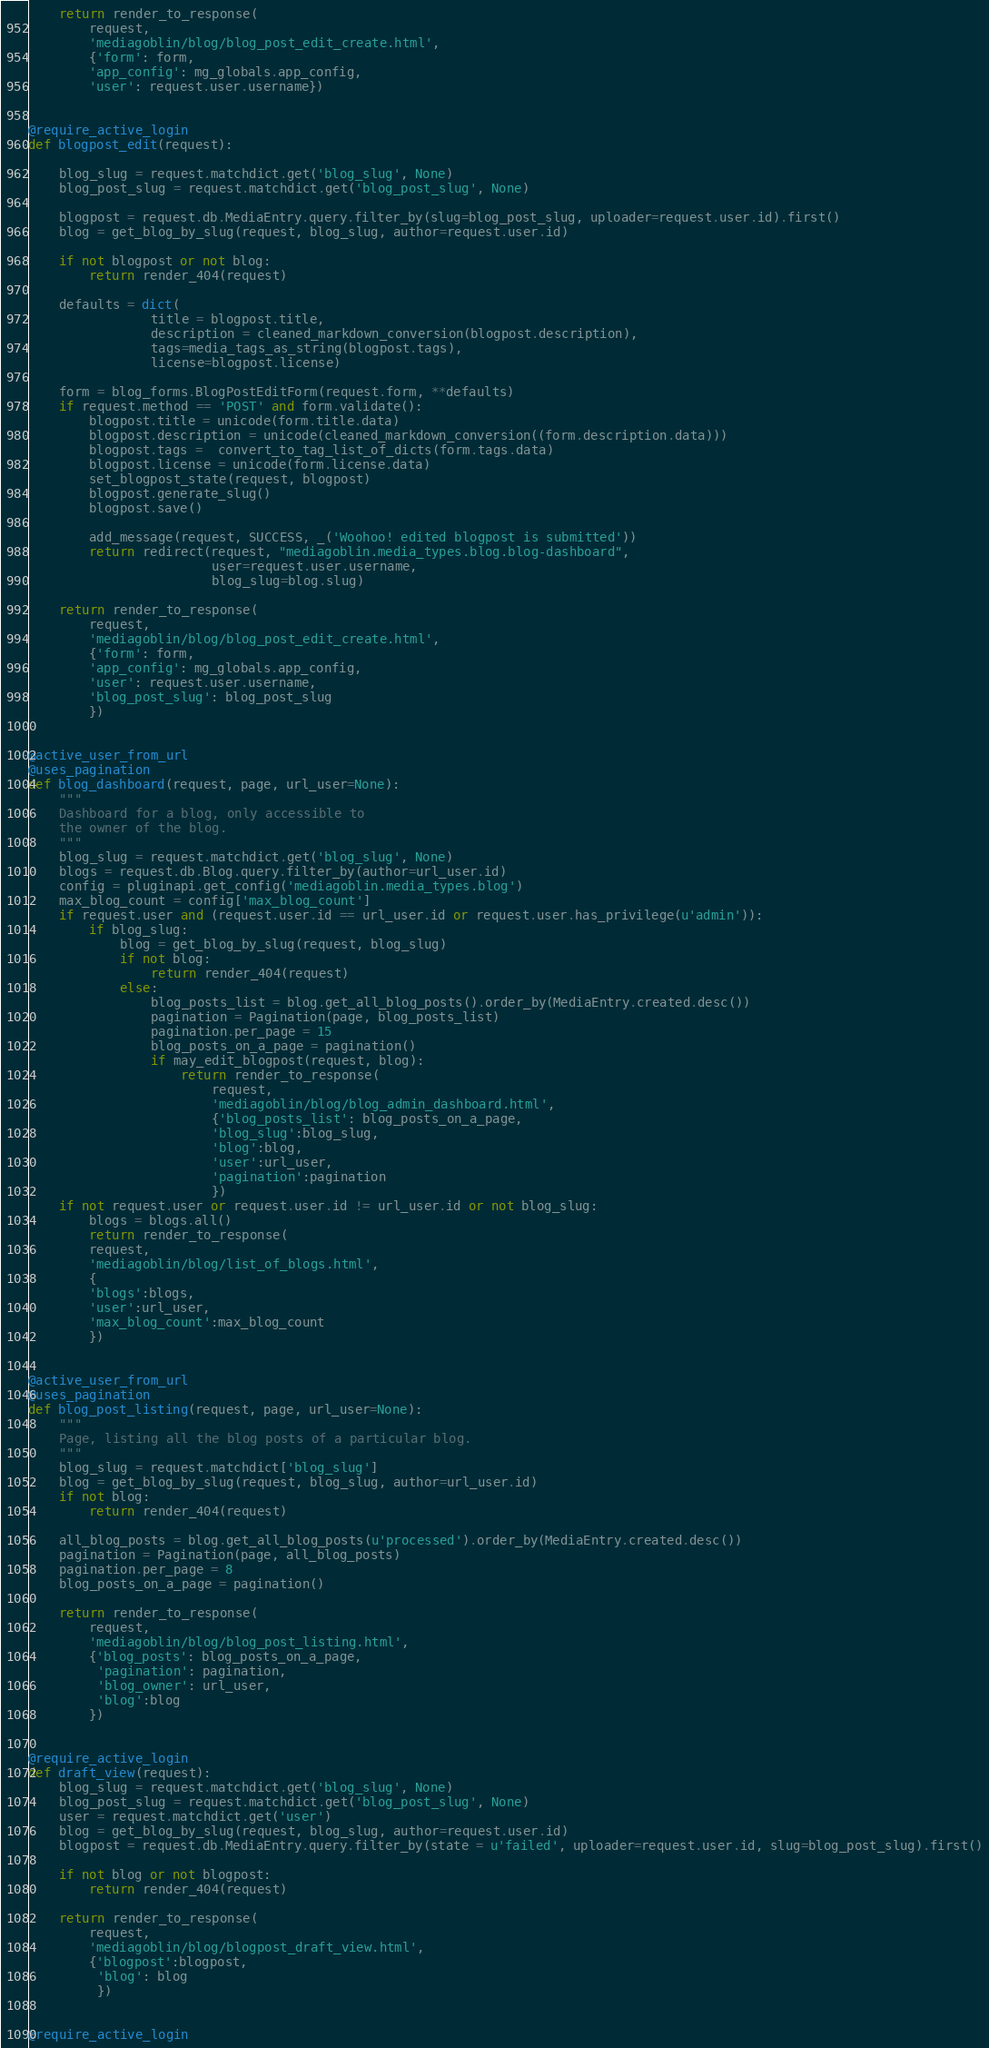Convert code to text. <code><loc_0><loc_0><loc_500><loc_500><_Python_>
    return render_to_response(
        request,
        'mediagoblin/blog/blog_post_edit_create.html',
        {'form': form,
        'app_config': mg_globals.app_config,
        'user': request.user.username})


@require_active_login
def blogpost_edit(request):
    
    blog_slug = request.matchdict.get('blog_slug', None)
    blog_post_slug = request.matchdict.get('blog_post_slug', None)

    blogpost = request.db.MediaEntry.query.filter_by(slug=blog_post_slug, uploader=request.user.id).first()
    blog = get_blog_by_slug(request, blog_slug, author=request.user.id)

    if not blogpost or not blog:
        return render_404(request)

    defaults = dict(
                title = blogpost.title,
                description = cleaned_markdown_conversion(blogpost.description),
                tags=media_tags_as_string(blogpost.tags),
                license=blogpost.license)

    form = blog_forms.BlogPostEditForm(request.form, **defaults)
    if request.method == 'POST' and form.validate():
        blogpost.title = unicode(form.title.data)
        blogpost.description = unicode(cleaned_markdown_conversion((form.description.data)))
        blogpost.tags =  convert_to_tag_list_of_dicts(form.tags.data)
        blogpost.license = unicode(form.license.data)
        set_blogpost_state(request, blogpost)
        blogpost.generate_slug()
        blogpost.save()

        add_message(request, SUCCESS, _('Woohoo! edited blogpost is submitted'))
        return redirect(request, "mediagoblin.media_types.blog.blog-dashboard",
                        user=request.user.username,
                        blog_slug=blog.slug)

    return render_to_response(
        request,
        'mediagoblin/blog/blog_post_edit_create.html',
        {'form': form,
        'app_config': mg_globals.app_config,
        'user': request.user.username,
        'blog_post_slug': blog_post_slug
        })


@active_user_from_url
@uses_pagination
def blog_dashboard(request, page, url_user=None):
    """
    Dashboard for a blog, only accessible to
    the owner of the blog.
    """
    blog_slug = request.matchdict.get('blog_slug', None)
    blogs = request.db.Blog.query.filter_by(author=url_user.id)
    config = pluginapi.get_config('mediagoblin.media_types.blog')
    max_blog_count = config['max_blog_count']
    if request.user and (request.user.id == url_user.id or request.user.has_privilege(u'admin')):
        if blog_slug:
            blog = get_blog_by_slug(request, blog_slug)
            if not blog:
                return render_404(request)
            else:
                blog_posts_list = blog.get_all_blog_posts().order_by(MediaEntry.created.desc())
                pagination = Pagination(page, blog_posts_list)
                pagination.per_page = 15
                blog_posts_on_a_page = pagination()
                if may_edit_blogpost(request, blog):
                    return render_to_response(
                        request,
                        'mediagoblin/blog/blog_admin_dashboard.html',
                        {'blog_posts_list': blog_posts_on_a_page,
                        'blog_slug':blog_slug,
                        'blog':blog,
                        'user':url_user,
                        'pagination':pagination
                        })
    if not request.user or request.user.id != url_user.id or not blog_slug:
        blogs = blogs.all()
        return render_to_response(
        request,
        'mediagoblin/blog/list_of_blogs.html',
        {
        'blogs':blogs,
        'user':url_user,
        'max_blog_count':max_blog_count
        })


@active_user_from_url
@uses_pagination
def blog_post_listing(request, page, url_user=None):
    """
    Page, listing all the blog posts of a particular blog.
    """
    blog_slug = request.matchdict['blog_slug']
    blog = get_blog_by_slug(request, blog_slug, author=url_user.id)
    if not blog:
        return render_404(request)

    all_blog_posts = blog.get_all_blog_posts(u'processed').order_by(MediaEntry.created.desc())
    pagination = Pagination(page, all_blog_posts)
    pagination.per_page = 8
    blog_posts_on_a_page = pagination()

    return render_to_response(
        request,
        'mediagoblin/blog/blog_post_listing.html',
        {'blog_posts': blog_posts_on_a_page,
         'pagination': pagination,
         'blog_owner': url_user,
         'blog':blog
        })
        

@require_active_login
def draft_view(request):
    blog_slug = request.matchdict.get('blog_slug', None)
    blog_post_slug = request.matchdict.get('blog_post_slug', None)
    user = request.matchdict.get('user')
    blog = get_blog_by_slug(request, blog_slug, author=request.user.id)
    blogpost = request.db.MediaEntry.query.filter_by(state = u'failed', uploader=request.user.id, slug=blog_post_slug).first()

    if not blog or not blogpost:
        return render_404(request)

    return render_to_response(
        request,
        'mediagoblin/blog/blogpost_draft_view.html',
        {'blogpost':blogpost,
         'blog': blog
         })
  
         
@require_active_login</code> 